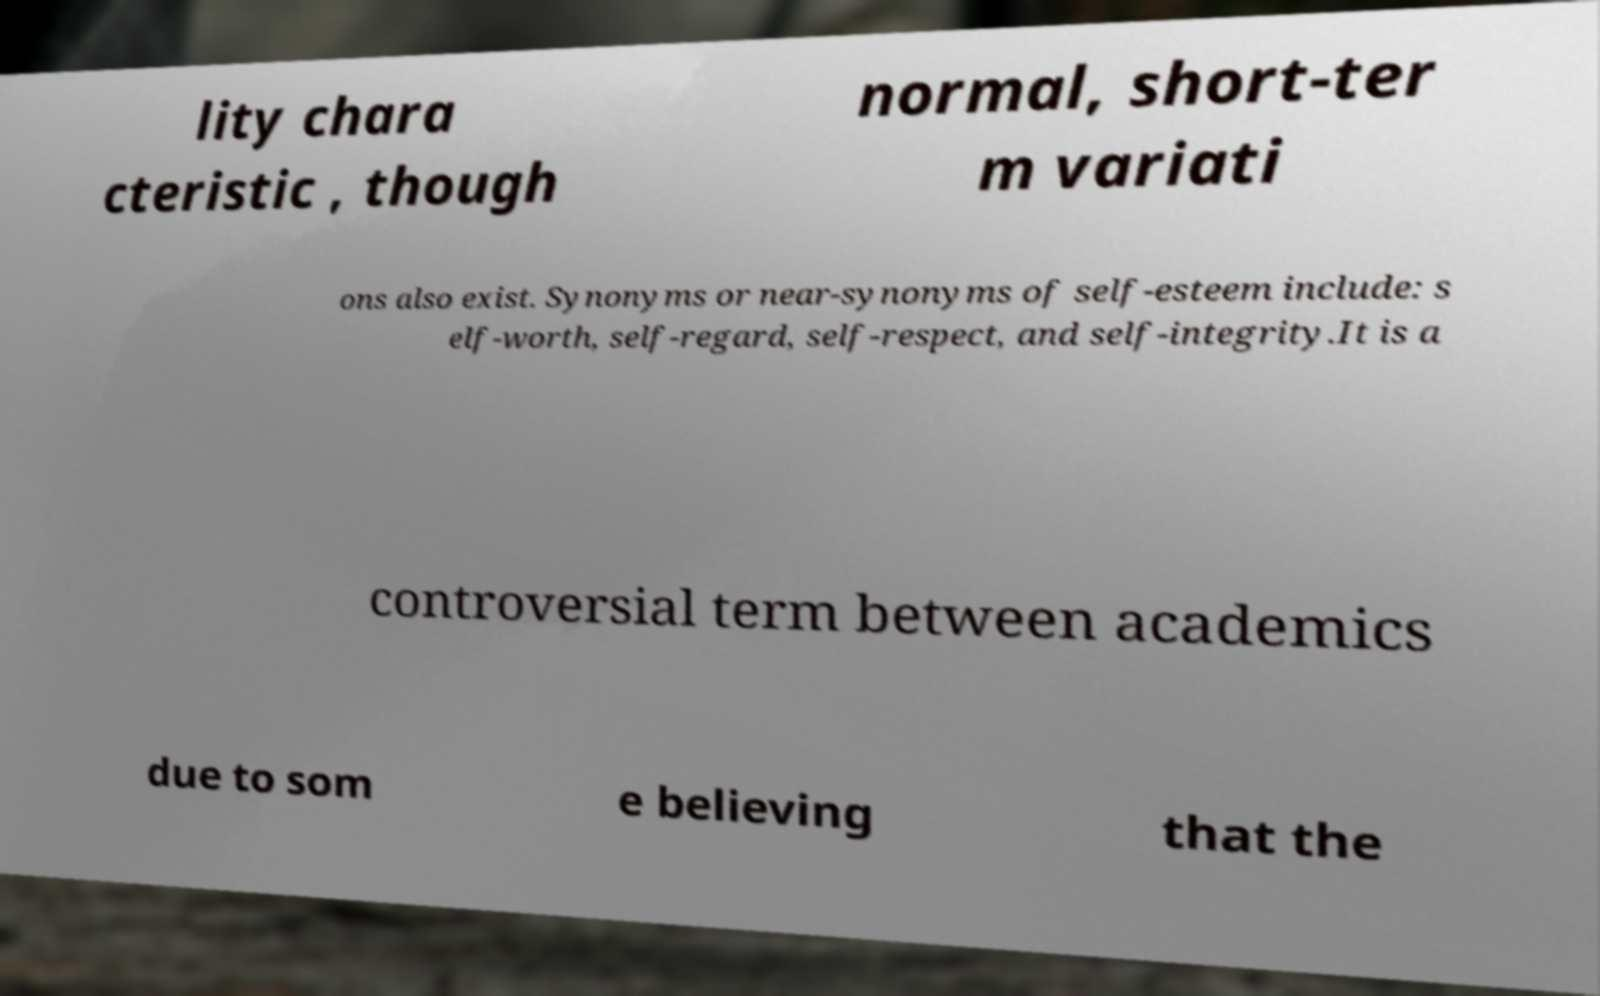Please read and relay the text visible in this image. What does it say? lity chara cteristic , though normal, short-ter m variati ons also exist. Synonyms or near-synonyms of self-esteem include: s elf-worth, self-regard, self-respect, and self-integrity.It is a controversial term between academics due to som e believing that the 